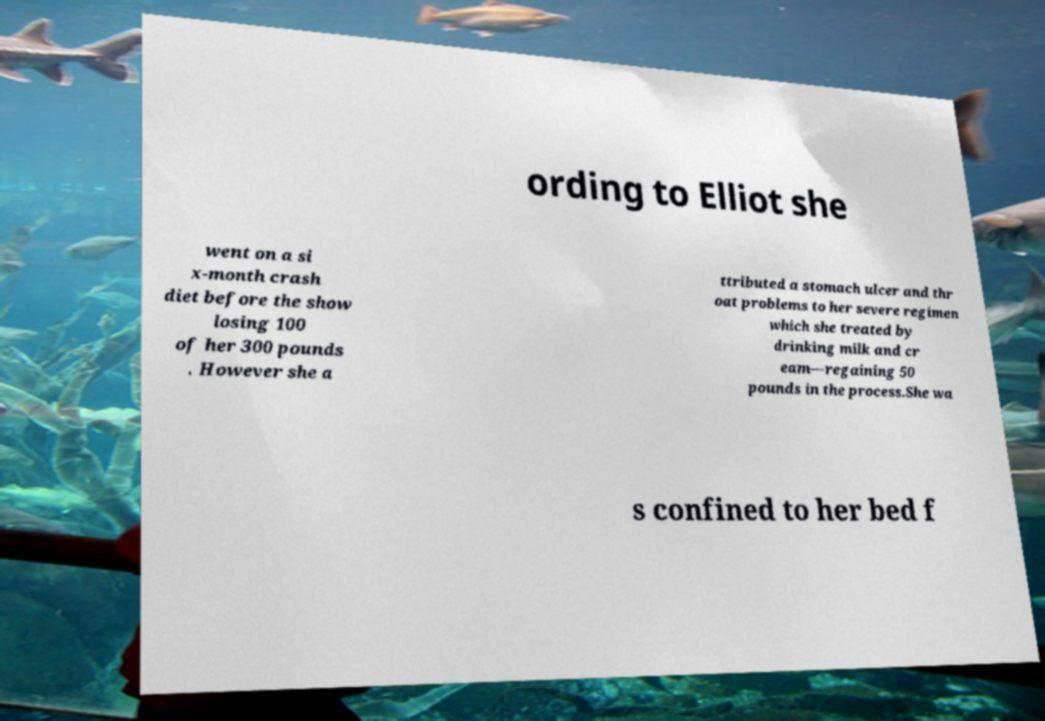Can you read and provide the text displayed in the image?This photo seems to have some interesting text. Can you extract and type it out for me? ording to Elliot she went on a si x-month crash diet before the show losing 100 of her 300 pounds . However she a ttributed a stomach ulcer and thr oat problems to her severe regimen which she treated by drinking milk and cr eam—regaining 50 pounds in the process.She wa s confined to her bed f 